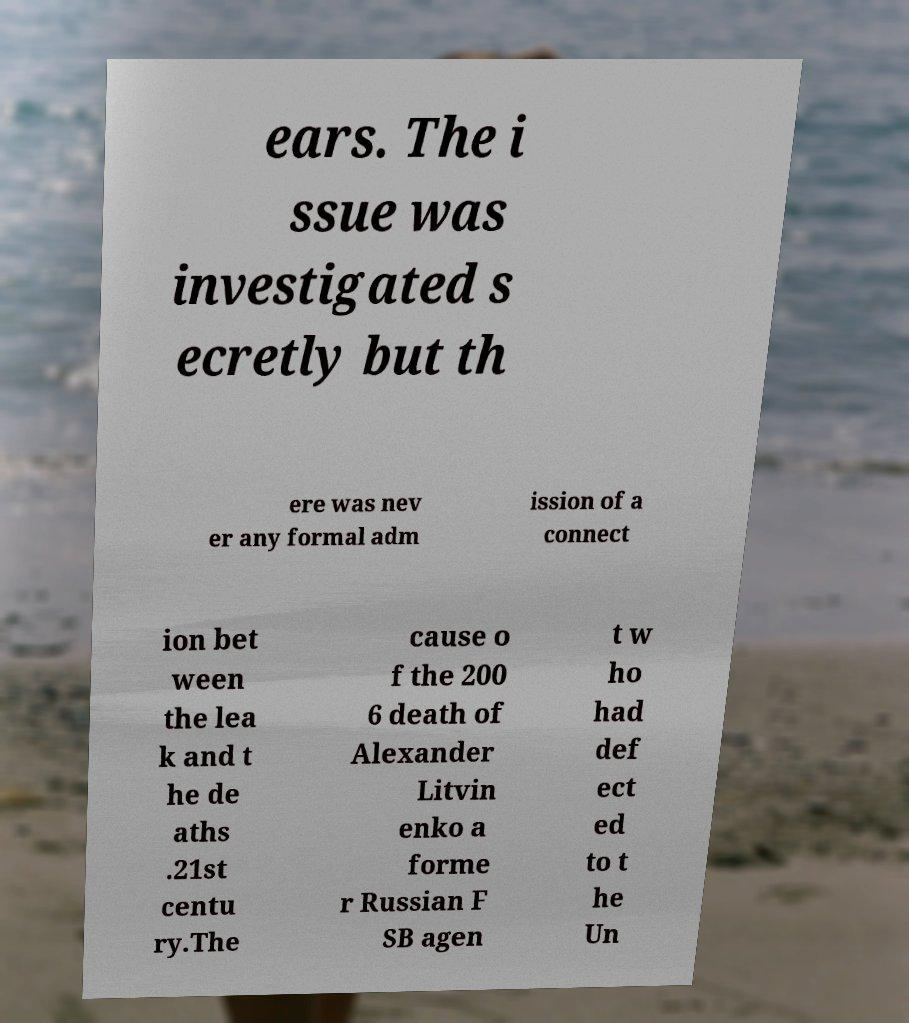I need the written content from this picture converted into text. Can you do that? ears. The i ssue was investigated s ecretly but th ere was nev er any formal adm ission of a connect ion bet ween the lea k and t he de aths .21st centu ry.The cause o f the 200 6 death of Alexander Litvin enko a forme r Russian F SB agen t w ho had def ect ed to t he Un 